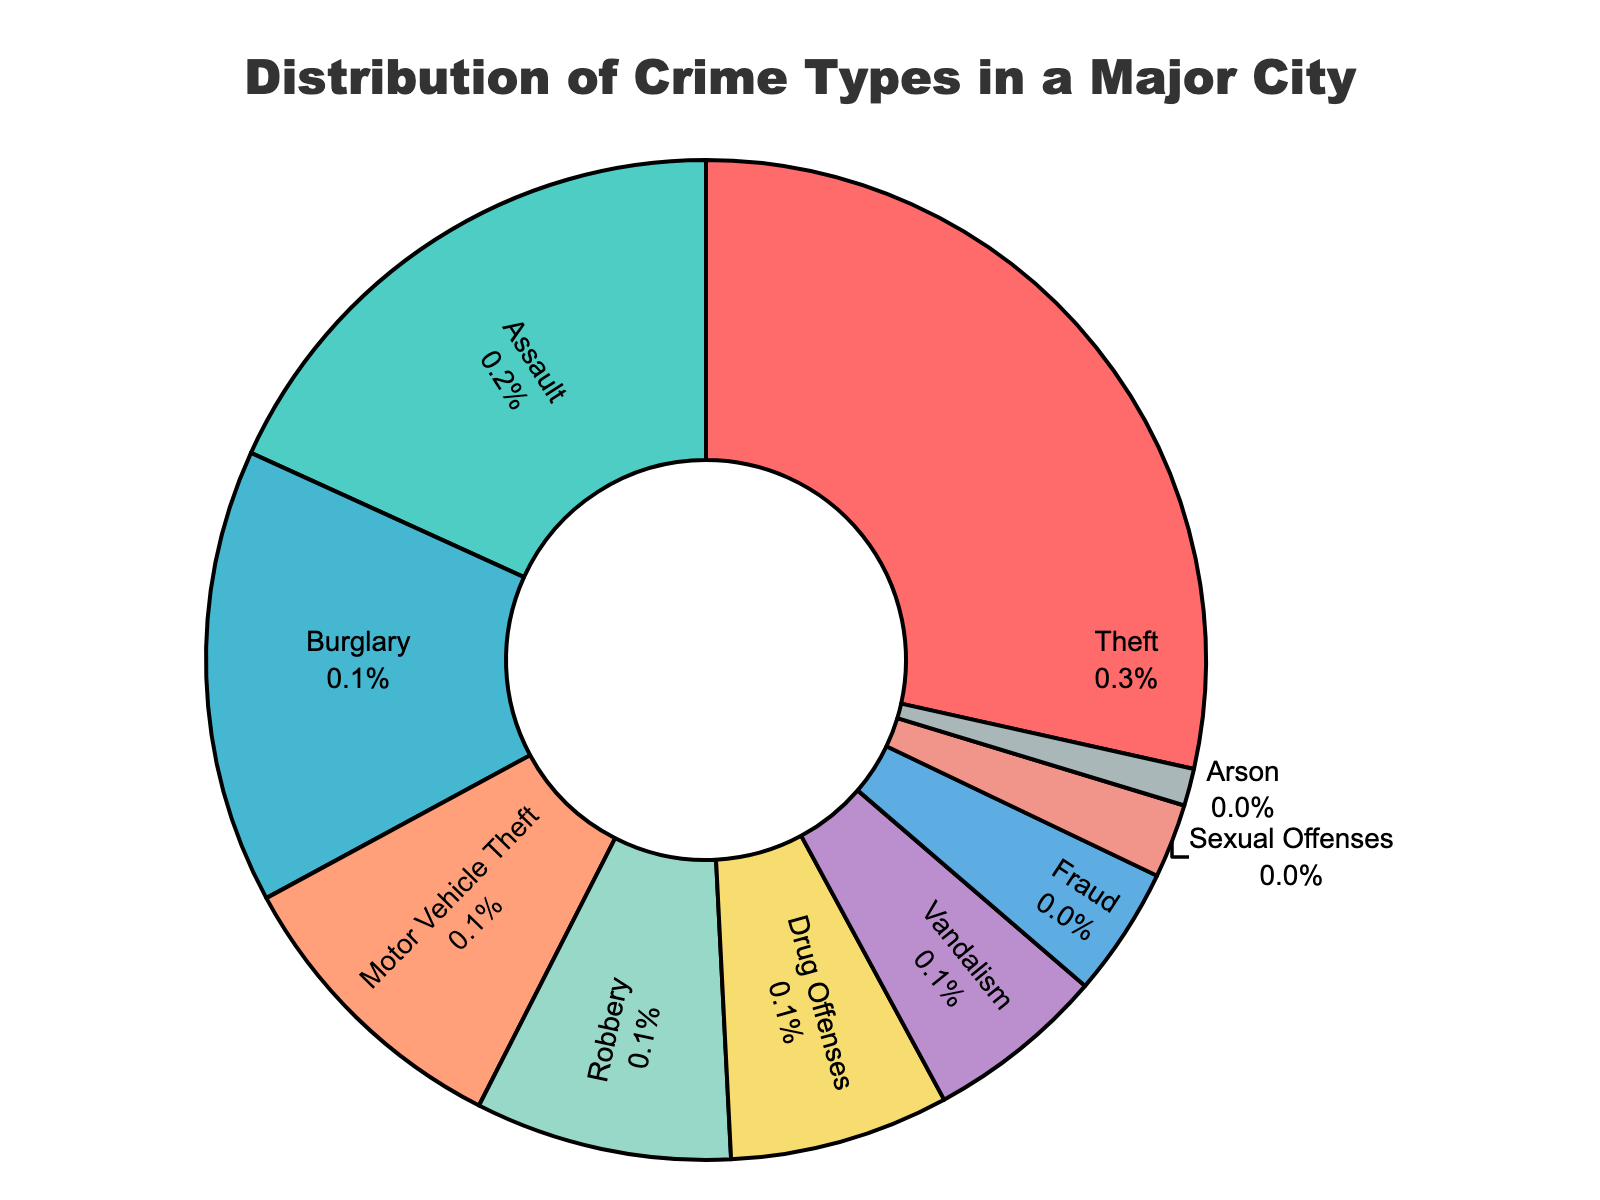What's the most common type of crime in the city? The most common crime type can be identified by looking at the largest section in the pie chart. According to the pie chart, the largest section is for Theft.
Answer: Theft What percentage of crimes are drug offenses? The section labeled "Drug Offenses" shows the percentage directly in the pie chart. The percentage for Drug Offenses is 7.1%.
Answer: 7.1% Is the percentage of Assault crimes higher than that of Robbery crimes? By comparing the sections labeled "Assault" and "Robbery" in the pie chart, we can see the percentages. Assault has 18.2%, while Robbery has 8.3%. Since 18.2% is greater than 8.3%, the percentage of Assault crimes is higher.
Answer: Yes How much higher is the percentage of Motor Vehicle Theft compared to Arson? The section for Motor Vehicle Theft indicates 9.6%, and the section for Arson indicates 1.2%. Substracting these values gives us the difference: 9.6% - 1.2% = 8.4%.
Answer: 8.4% What is the combined percentage of Burglary and Vandalism crimes? To find the combined percentage, we add the individual percentages from the sections labeled "Burglary" and "Vandalism". Burglary is 14.7% and Vandalism is 5.8%. So, 14.7% + 5.8% = 20.5%.
Answer: 20.5% Which crime type has the smallest percentage? The smallest section in the pie chart represents the crime type with the smallest percentage. According to the chart, Arson has the smallest section.
Answer: Arson Are sexual offenses less common than fraud offenses? By comparing the sections labeled "Sexual Offenses" and "Fraud" in the pie chart, we can see the percentages. Sexual Offenses is 2.4%, while Fraud is 4.2%. Since 2.4% is less than 4.2%, sexual offenses are less common.
Answer: Yes What is the combined percentage of Assault, Robbery, and Vandalism? To find the combined percentage, we add the individual percentages from the sections labeled "Assault," "Robbery," and "Vandalism". Assault is 18.2%, Robbery is 8.3%, and Vandalism is 5.8%. So, 18.2% + 8.3% + 5.8% = 32.3%.
Answer: 32.3% Does fraud make up more than 5% of the total crime distribution? By looking at the section labeled "Fraud" in the pie chart, we can see that Fraud is 4.2%. Since 4.2% is less than 5%, fraud does not make up more than 5% of the total distribution.
Answer: No 